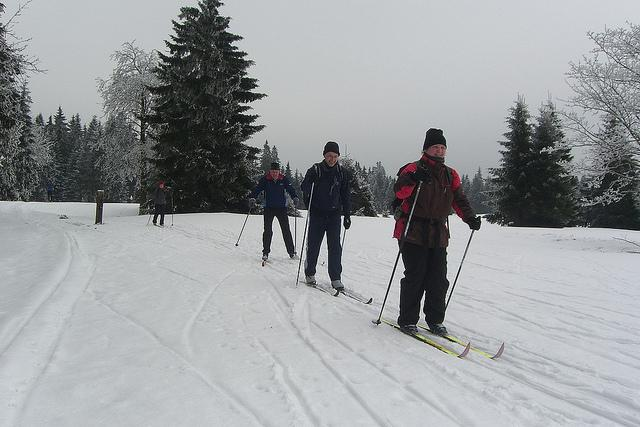What is needed for this activity?

Choices:
A) sun
B) sand
C) snow
D) rain snow 